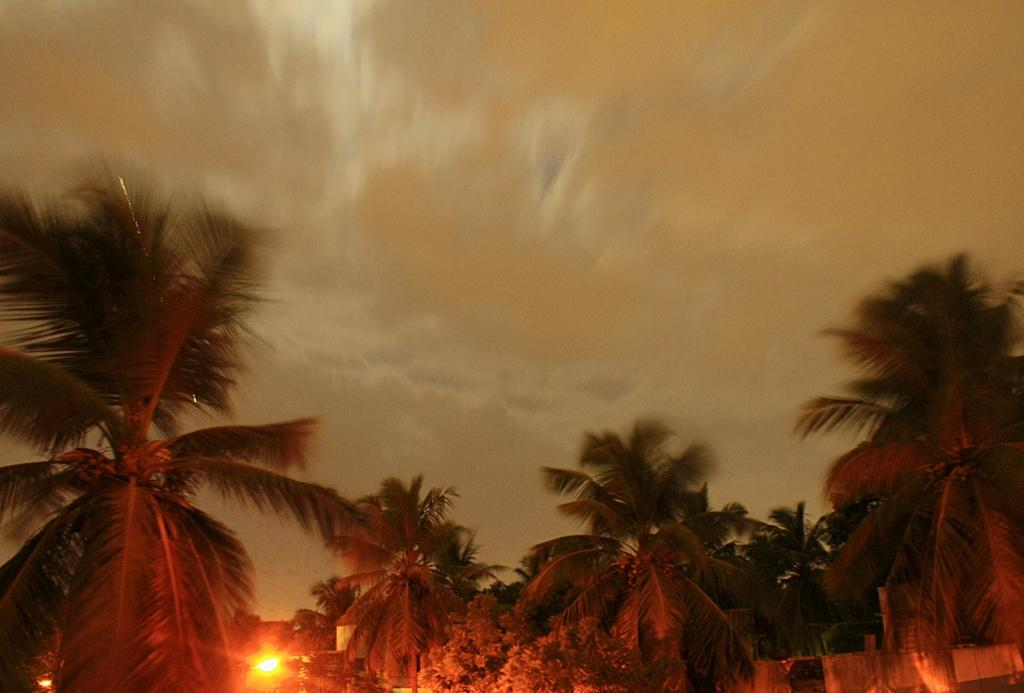What type of natural elements can be seen in the image? There are trees in the image. What artificial elements can be seen in the image? There are lights in the image. What is visible in the background of the image? The sky is visible in the background of the image. How much does the sea weigh in the image? There is no sea present in the image, so it is not possible to determine its weight. 